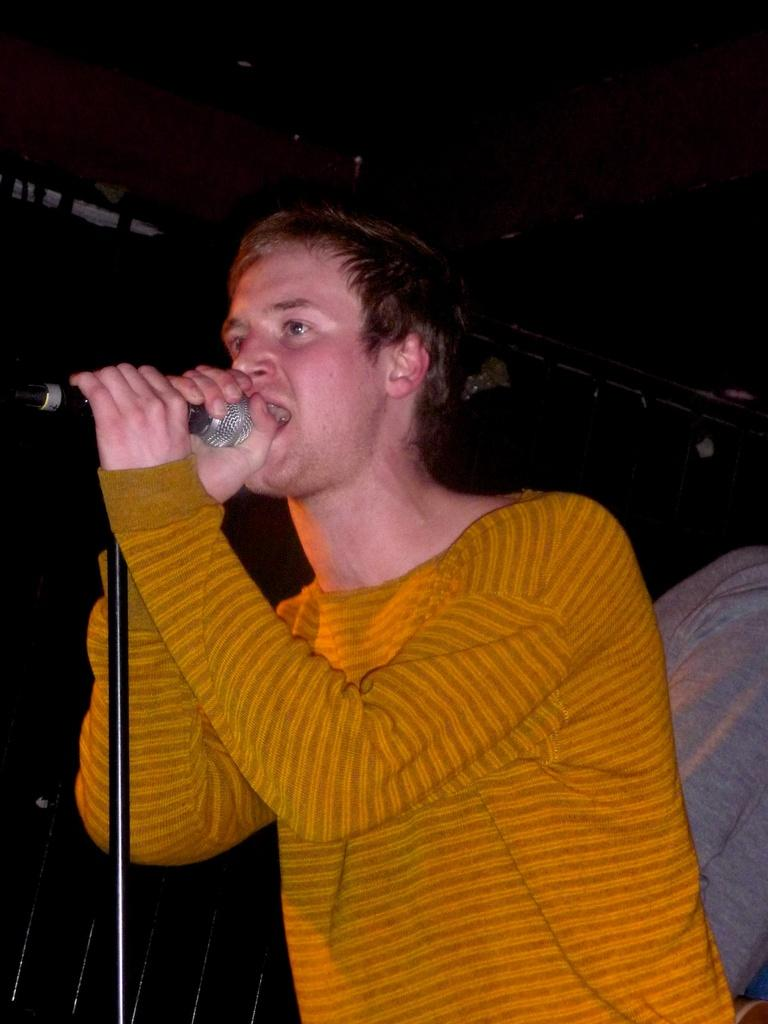What is the main subject of the image? There is a person in the image. What is the person holding in the image? The person is holding a microphone. What is the microphone attached to in the image? The microphone has a stand. What is the person doing with the microphone? The person is singing. What can be observed about the background of the image? The background of the image is dark. Can you see a fireman putting out a fire in the image? No, there is no fireman or fire present in the image. Is there an arch visible in the background of the image? No, there is no arch present in the image. 